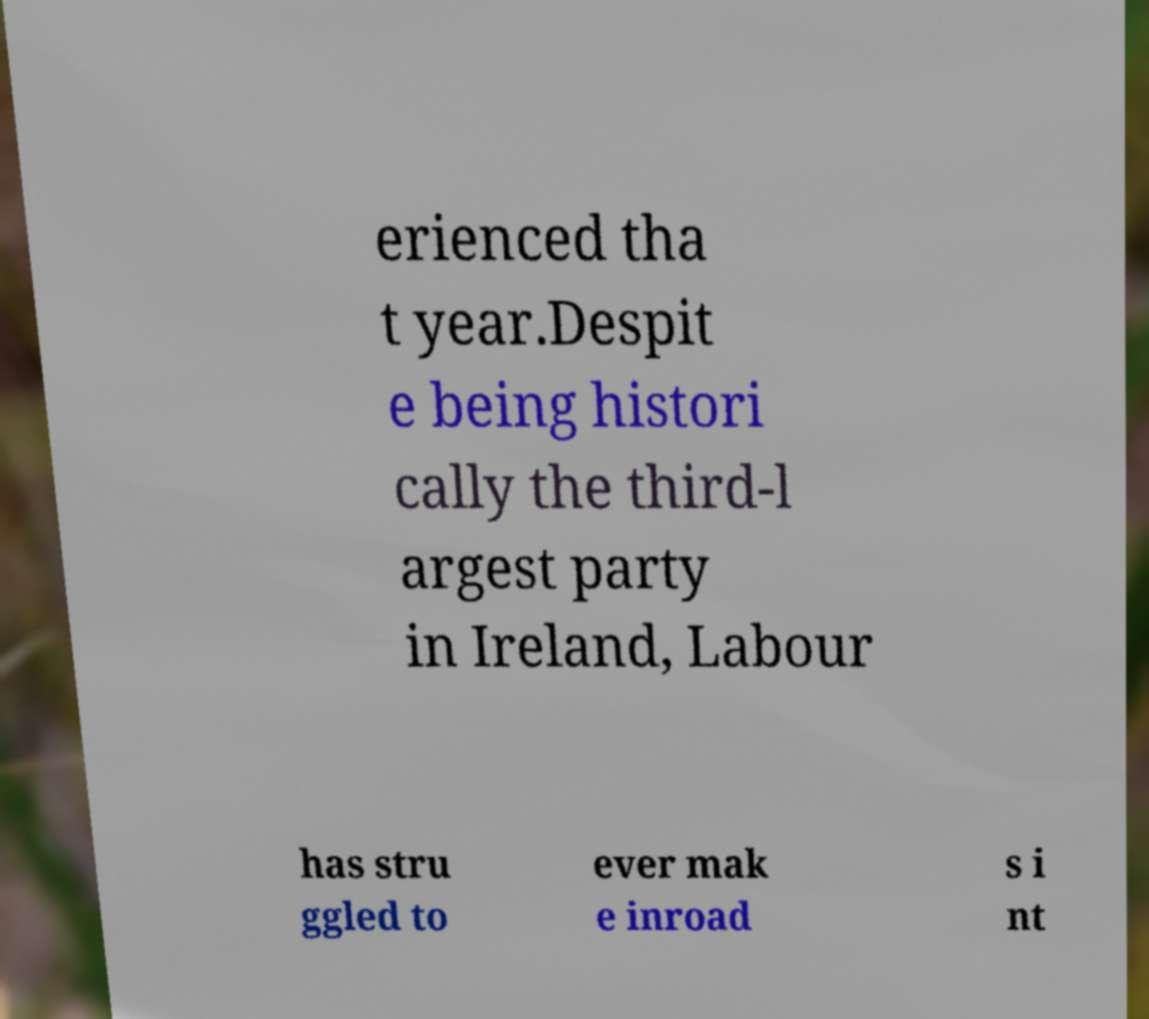Could you extract and type out the text from this image? erienced tha t year.Despit e being histori cally the third-l argest party in Ireland, Labour has stru ggled to ever mak e inroad s i nt 